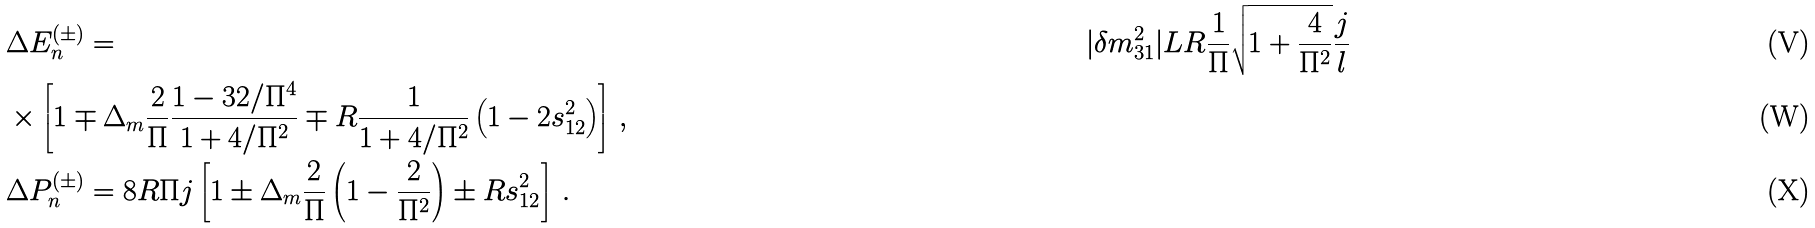<formula> <loc_0><loc_0><loc_500><loc_500>& \Delta E _ { n } ^ { ( \pm ) } = & | \delta m ^ { 2 } _ { 3 1 } | L R \frac { 1 } { \Pi } \sqrt { 1 + \frac { 4 } { \Pi ^ { 2 } } } \frac { j } { l } \\ & \times \left [ 1 \mp \Delta _ { m } \frac { 2 } { \Pi } \frac { 1 - 3 2 / \Pi ^ { 4 } } { 1 + 4 / \Pi ^ { 2 } } \mp R \frac { 1 } { 1 + 4 / \Pi ^ { 2 } } \left ( 1 - 2 s _ { 1 2 } ^ { 2 } \right ) \right ] \, , \\ & \Delta P _ { n } ^ { ( \pm ) } = 8 R \Pi j \left [ 1 \pm \Delta _ { m } \frac { 2 } { \Pi } \left ( 1 - \frac { 2 } { \Pi ^ { 2 } } \right ) \pm R s _ { 1 2 } ^ { 2 } \right ] \, .</formula> 